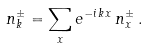Convert formula to latex. <formula><loc_0><loc_0><loc_500><loc_500>n _ { k } ^ { \pm } = \sum _ { x } e ^ { - i \, { k x } } \, n _ { x } ^ { \pm } \, .</formula> 